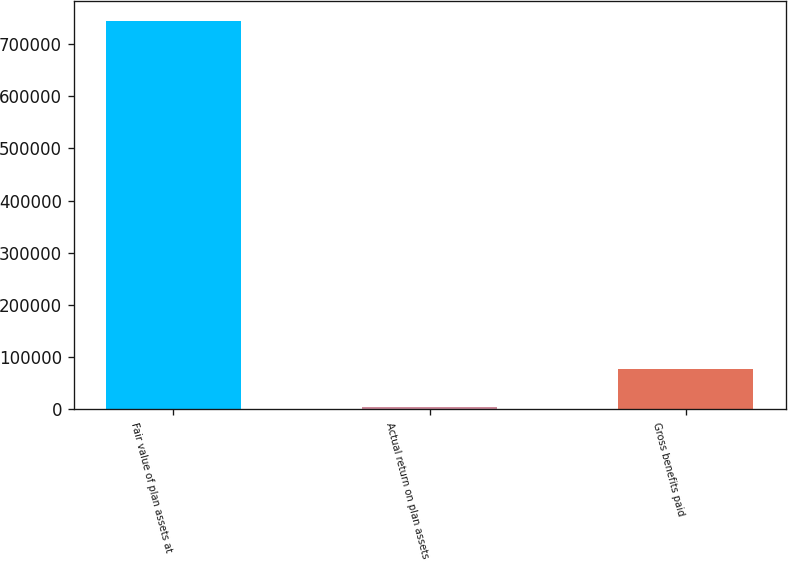Convert chart to OTSL. <chart><loc_0><loc_0><loc_500><loc_500><bar_chart><fcel>Fair value of plan assets at<fcel>Actual return on plan assets<fcel>Gross benefits paid<nl><fcel>744689<fcel>3729<fcel>77825<nl></chart> 